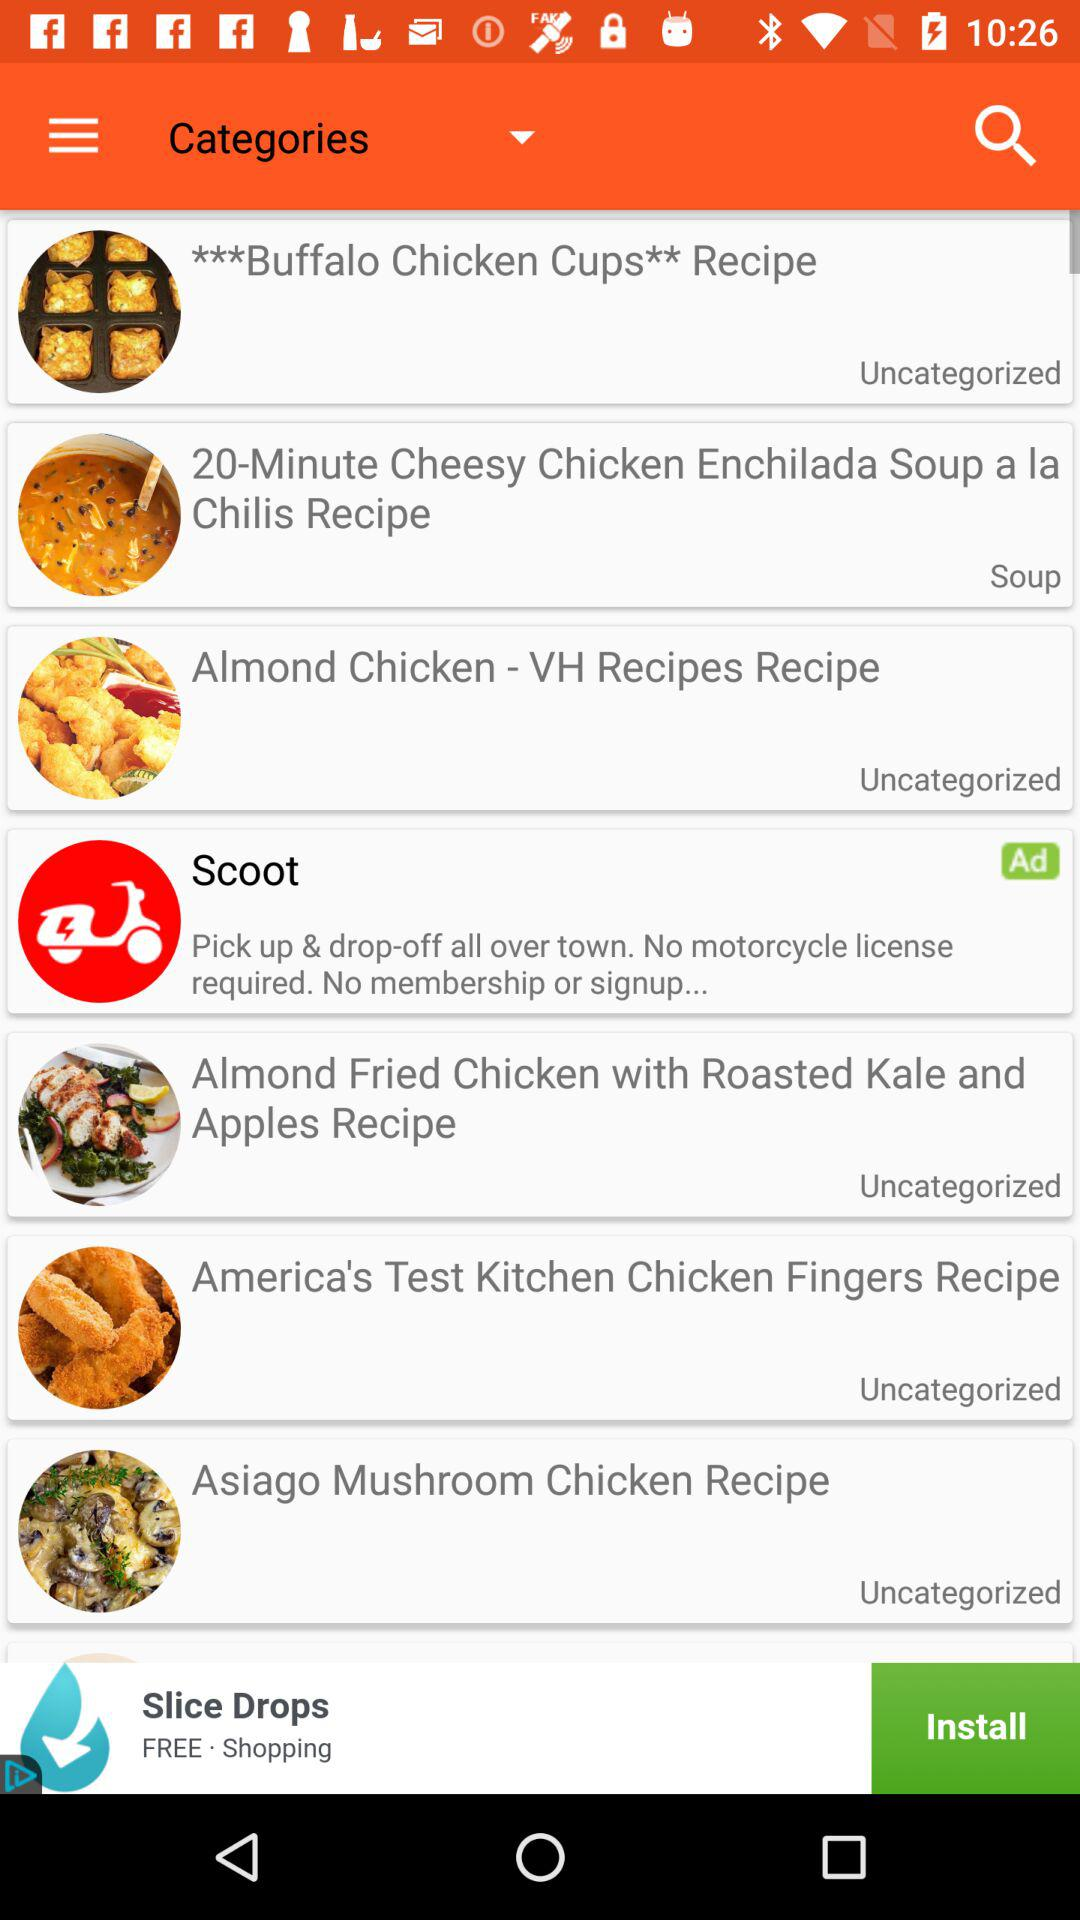What's the category of Almond Chicken? The category of Almond Chicken is Uncategorized. 